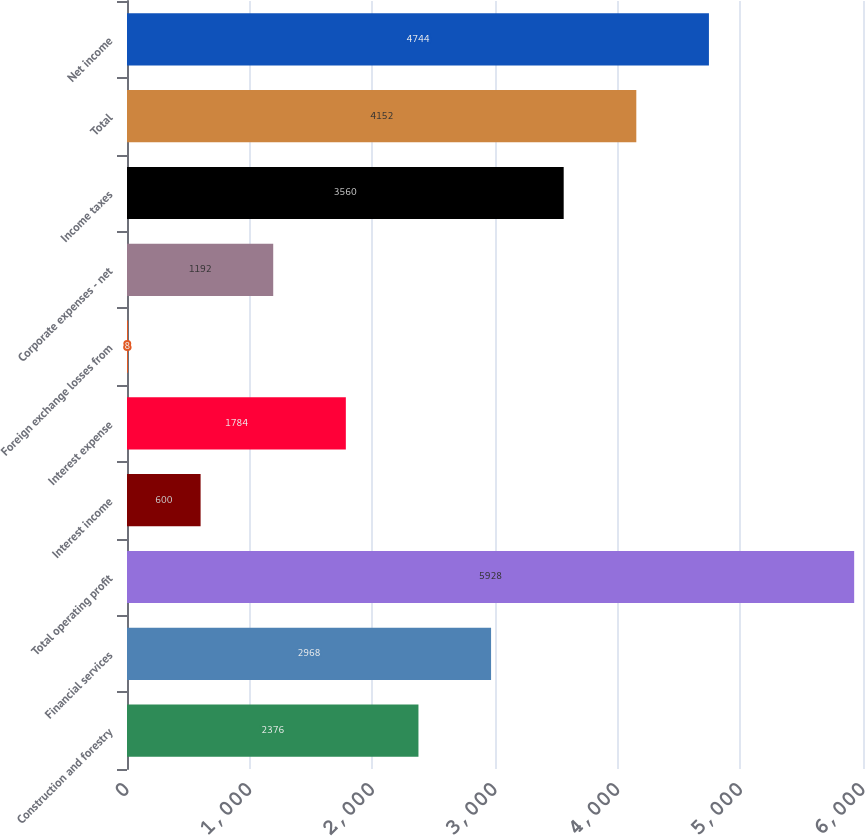Convert chart to OTSL. <chart><loc_0><loc_0><loc_500><loc_500><bar_chart><fcel>Construction and forestry<fcel>Financial services<fcel>Total operating profit<fcel>Interest income<fcel>Interest expense<fcel>Foreign exchange losses from<fcel>Corporate expenses - net<fcel>Income taxes<fcel>Total<fcel>Net income<nl><fcel>2376<fcel>2968<fcel>5928<fcel>600<fcel>1784<fcel>8<fcel>1192<fcel>3560<fcel>4152<fcel>4744<nl></chart> 